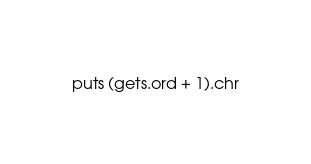<code> <loc_0><loc_0><loc_500><loc_500><_Ruby_>puts (gets.ord + 1).chr</code> 